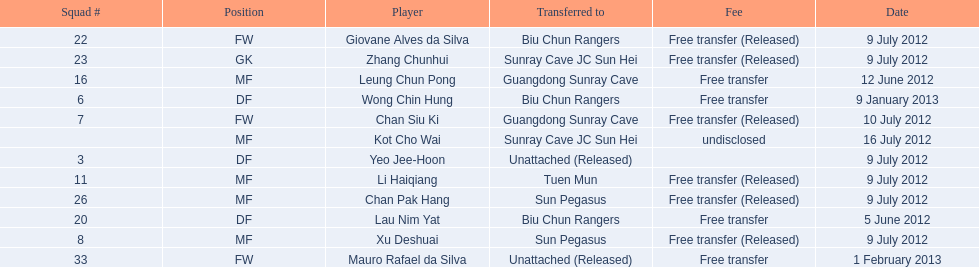Which players are listed? Lau Nim Yat, Leung Chun Pong, Yeo Jee-Hoon, Xu Deshuai, Li Haiqiang, Giovane Alves da Silva, Zhang Chunhui, Chan Pak Hang, Chan Siu Ki, Kot Cho Wai, Wong Chin Hung, Mauro Rafael da Silva. Which dates were players transferred to the biu chun rangers? 5 June 2012, 9 July 2012, 9 January 2013. Of those which is the date for wong chin hung? 9 January 2013. 